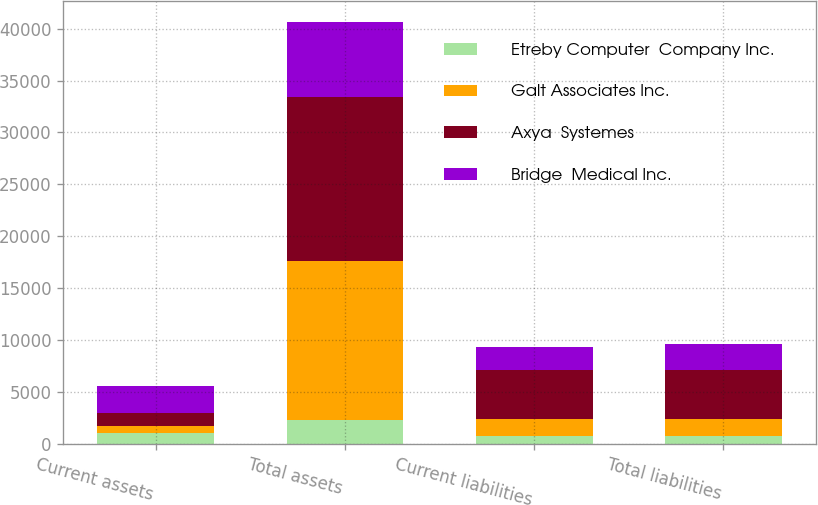Convert chart to OTSL. <chart><loc_0><loc_0><loc_500><loc_500><stacked_bar_chart><ecel><fcel>Current assets<fcel>Total assets<fcel>Current liabilities<fcel>Total liabilities<nl><fcel>Etreby Computer  Company Inc.<fcel>1002<fcel>2244<fcel>748<fcel>748<nl><fcel>Galt Associates Inc.<fcel>751<fcel>15372<fcel>1606<fcel>1606<nl><fcel>Axya  Systemes<fcel>1172<fcel>15802<fcel>4748<fcel>4783<nl><fcel>Bridge  Medical Inc.<fcel>2680<fcel>7209<fcel>2244<fcel>2483<nl></chart> 